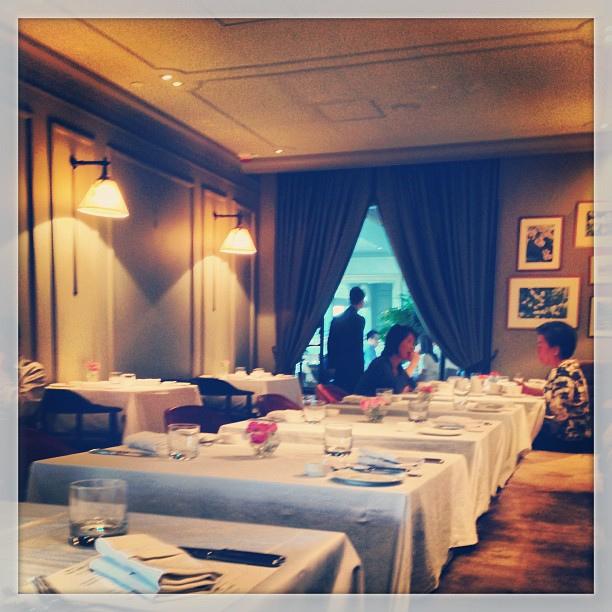Is there recessed lighting in the room?
Write a very short answer. Yes. What kind of room is this?
Be succinct. Dining room. How many wall lamps in the room?
Short answer required. 2. What color is the plate?
Concise answer only. White. How many towels are visible?
Keep it brief. 3. 